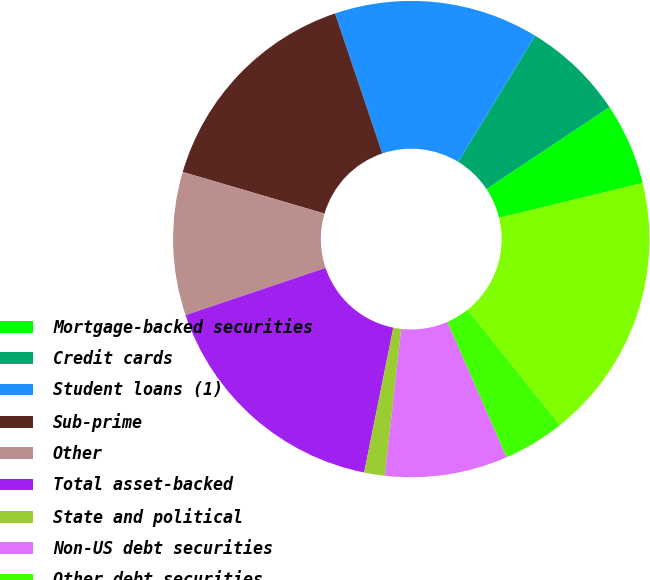<chart> <loc_0><loc_0><loc_500><loc_500><pie_chart><fcel>Mortgage-backed securities<fcel>Credit cards<fcel>Student loans (1)<fcel>Sub-prime<fcel>Other<fcel>Total asset-backed<fcel>State and political<fcel>Non-US debt securities<fcel>Other debt securities<fcel>Total<nl><fcel>5.56%<fcel>6.95%<fcel>13.89%<fcel>15.27%<fcel>9.72%<fcel>16.66%<fcel>1.4%<fcel>8.33%<fcel>4.17%<fcel>18.05%<nl></chart> 